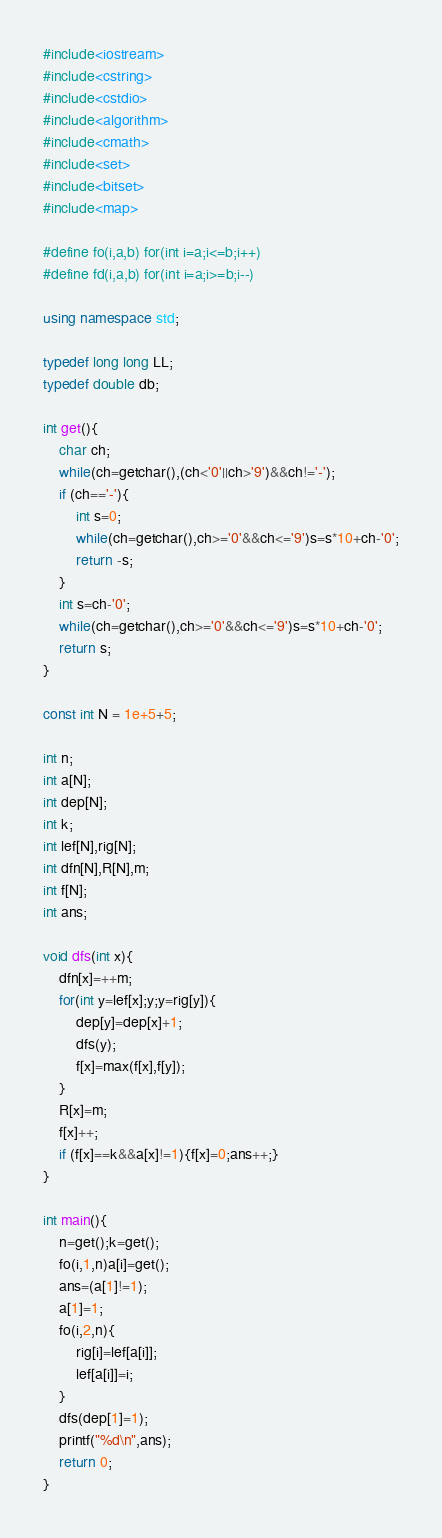<code> <loc_0><loc_0><loc_500><loc_500><_C++_>#include<iostream>
#include<cstring>
#include<cstdio>
#include<algorithm>
#include<cmath>
#include<set>
#include<bitset>
#include<map>

#define fo(i,a,b) for(int i=a;i<=b;i++)
#define fd(i,a,b) for(int i=a;i>=b;i--)

using namespace std;

typedef long long LL;
typedef double db;

int get(){
	char ch;
	while(ch=getchar(),(ch<'0'||ch>'9')&&ch!='-');
	if (ch=='-'){
		int s=0;
		while(ch=getchar(),ch>='0'&&ch<='9')s=s*10+ch-'0';
		return -s;
	}
	int s=ch-'0';
	while(ch=getchar(),ch>='0'&&ch<='9')s=s*10+ch-'0';
	return s;
}

const int N = 1e+5+5;

int n;
int a[N];
int dep[N];
int k;
int lef[N],rig[N];
int dfn[N],R[N],m;
int f[N];
int ans;

void dfs(int x){
	dfn[x]=++m;
	for(int y=lef[x];y;y=rig[y]){
		dep[y]=dep[x]+1;
		dfs(y);
		f[x]=max(f[x],f[y]);
	}
	R[x]=m;
	f[x]++;
	if (f[x]==k&&a[x]!=1){f[x]=0;ans++;}
}

int main(){
	n=get();k=get();
	fo(i,1,n)a[i]=get();
	ans=(a[1]!=1);
	a[1]=1;
	fo(i,2,n){
		rig[i]=lef[a[i]];
		lef[a[i]]=i;
	}
	dfs(dep[1]=1);
	printf("%d\n",ans);
	return 0;
}</code> 